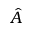<formula> <loc_0><loc_0><loc_500><loc_500>\hat { A }</formula> 